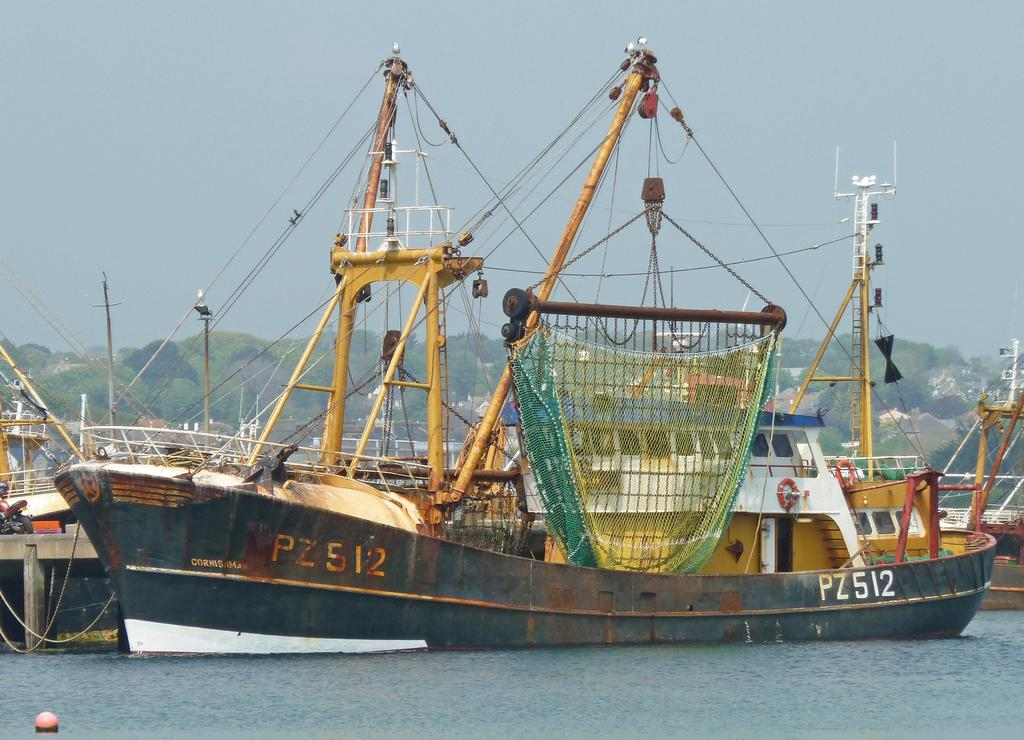What is the main subject of the image? The main subject of the image is boats on a water body. What can be seen in the background of the image? In the background of the image, there are hills, trees, and buildings. How is the sky depicted in the image? The sky is clear in the image. Can you see any blood stains on the boats in the image? There are no blood stains visible on the boats in the image. Is there any quicksand present near the boats in the image? There is no quicksand present near the boats in the image. 